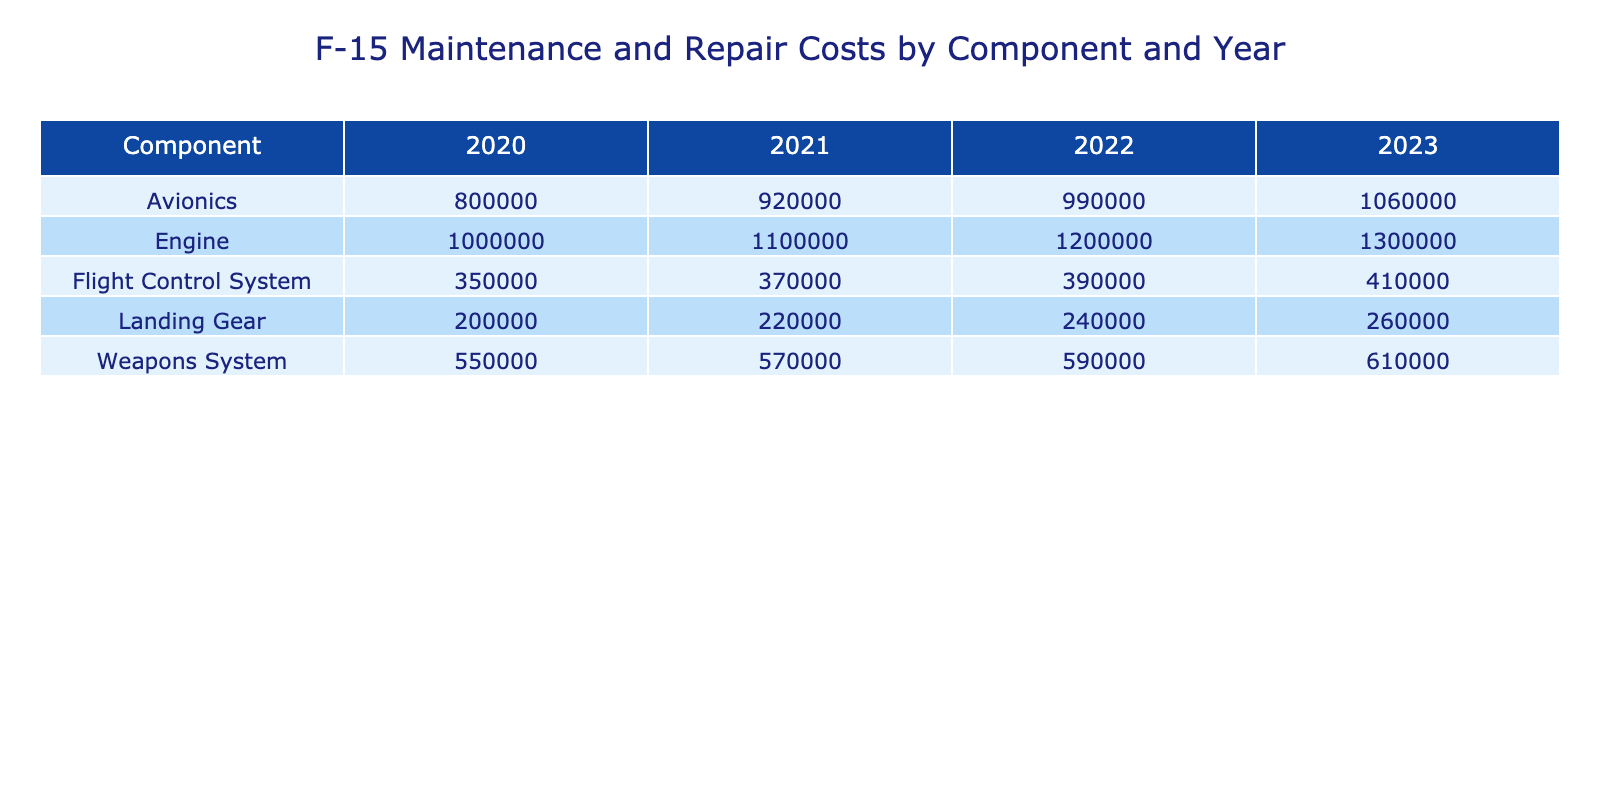What was the total maintenance cost for the Engine in 2022? In the table, I look for the row that corresponds to the Engine component for the year 2022. The maintenance cost listed is 900000.
Answer: 900000 Which component had the highest total cost in 2021? I check the total costs for each component in 2021. Engine had a total cost of 1100000, which is higher than all other components listed for that year.
Answer: Engine What is the average total cost for the Flight Control System over the years? I find the total costs for the Flight Control System across all years: 350000 (2020) + 370000 (2021) + 390000 (2022) + 410000 (2023) = 1520000. Then, I divide that sum by the number of years (4): 1520000 / 4 = 380000.
Answer: 380000 Did the landing gear's total costs increase every year from 2020 to 2023? I review the total costs for landing gear year by year: 200000 (2020), 220000 (2021), 240000 (2022), and 260000 (2023). Since each subsequent year shows a higher cost, the statement is true.
Answer: Yes What is the total increase in the repair costs for the Avionics component from 2020 to 2023? I examine the repair costs for Avionics: 300000 (2020) to 360000 (2023). The increase is calculated as 360000 - 300000 = 60000.
Answer: 60000 Which component had the lowest total cost in 2022? I check the total costs for each component in 2022: 990000 (Avionics), 1200000 (Engine), 240000 (Landing Gear), 390000 (Flight Control System), and 590000 (Weapons System). The Landing Gear had the lowest total cost at 240000.
Answer: Landing Gear What is the sum of the total costs for the Weapons System from 2020 to 2023? I sum the total costs for Weapons System over the years: 550000 (2020) + 570000 (2021) + 590000 (2022) + 610000 (2023) = 2320000.
Answer: 2320000 Was the maintenance cost for the Engine consistently above 800000 across all years? I check the maintenance costs for Engine over the years: 800000 (2020), 850000 (2021), 900000 (2022), and 950000 (2023). Since 800000 is not above 800000 for 2020, the statement is false.
Answer: No 